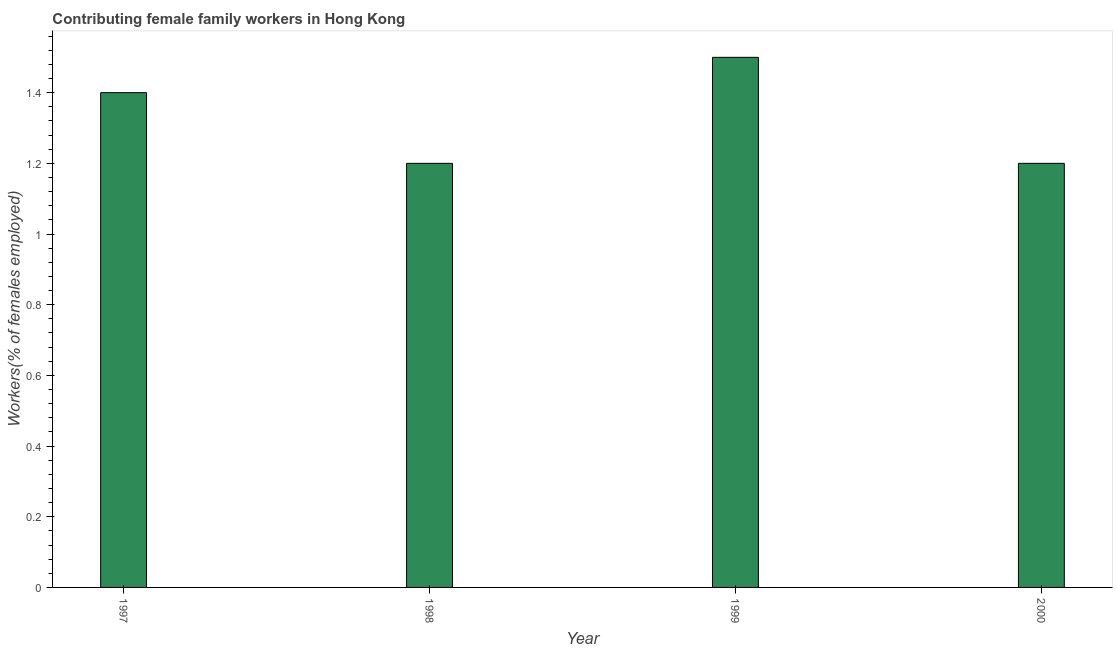What is the title of the graph?
Make the answer very short. Contributing female family workers in Hong Kong. What is the label or title of the Y-axis?
Your response must be concise. Workers(% of females employed). What is the contributing female family workers in 2000?
Ensure brevity in your answer.  1.2. Across all years, what is the maximum contributing female family workers?
Offer a very short reply. 1.5. Across all years, what is the minimum contributing female family workers?
Your response must be concise. 1.2. In which year was the contributing female family workers minimum?
Offer a terse response. 1998. What is the sum of the contributing female family workers?
Your answer should be compact. 5.3. What is the average contributing female family workers per year?
Provide a short and direct response. 1.32. What is the median contributing female family workers?
Provide a succinct answer. 1.3. What is the ratio of the contributing female family workers in 1999 to that in 2000?
Your answer should be compact. 1.25. Is the sum of the contributing female family workers in 1998 and 2000 greater than the maximum contributing female family workers across all years?
Your answer should be very brief. Yes. How many bars are there?
Ensure brevity in your answer.  4. What is the Workers(% of females employed) of 1997?
Keep it short and to the point. 1.4. What is the Workers(% of females employed) in 1998?
Offer a terse response. 1.2. What is the Workers(% of females employed) of 2000?
Ensure brevity in your answer.  1.2. What is the difference between the Workers(% of females employed) in 1997 and 2000?
Your response must be concise. 0.2. What is the difference between the Workers(% of females employed) in 1998 and 1999?
Offer a very short reply. -0.3. What is the difference between the Workers(% of females employed) in 1998 and 2000?
Provide a succinct answer. 0. What is the ratio of the Workers(% of females employed) in 1997 to that in 1998?
Provide a succinct answer. 1.17. What is the ratio of the Workers(% of females employed) in 1997 to that in 1999?
Provide a short and direct response. 0.93. What is the ratio of the Workers(% of females employed) in 1997 to that in 2000?
Keep it short and to the point. 1.17. 